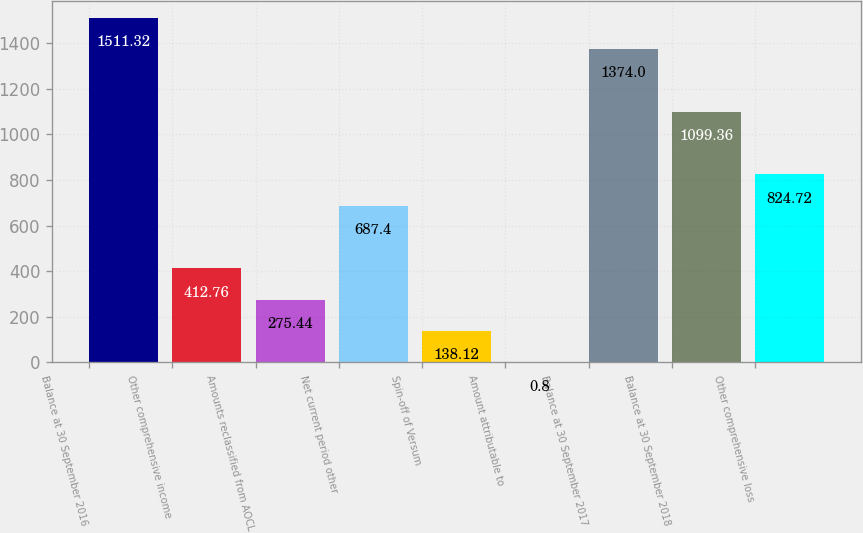<chart> <loc_0><loc_0><loc_500><loc_500><bar_chart><fcel>Balance at 30 September 2016<fcel>Other comprehensive income<fcel>Amounts reclassified from AOCL<fcel>Net current period other<fcel>Spin-off of Versum<fcel>Amount attributable to<fcel>Balance at 30 September 2017<fcel>Balance at 30 September 2018<fcel>Other comprehensive loss<nl><fcel>1511.32<fcel>412.76<fcel>275.44<fcel>687.4<fcel>138.12<fcel>0.8<fcel>1374<fcel>1099.36<fcel>824.72<nl></chart> 